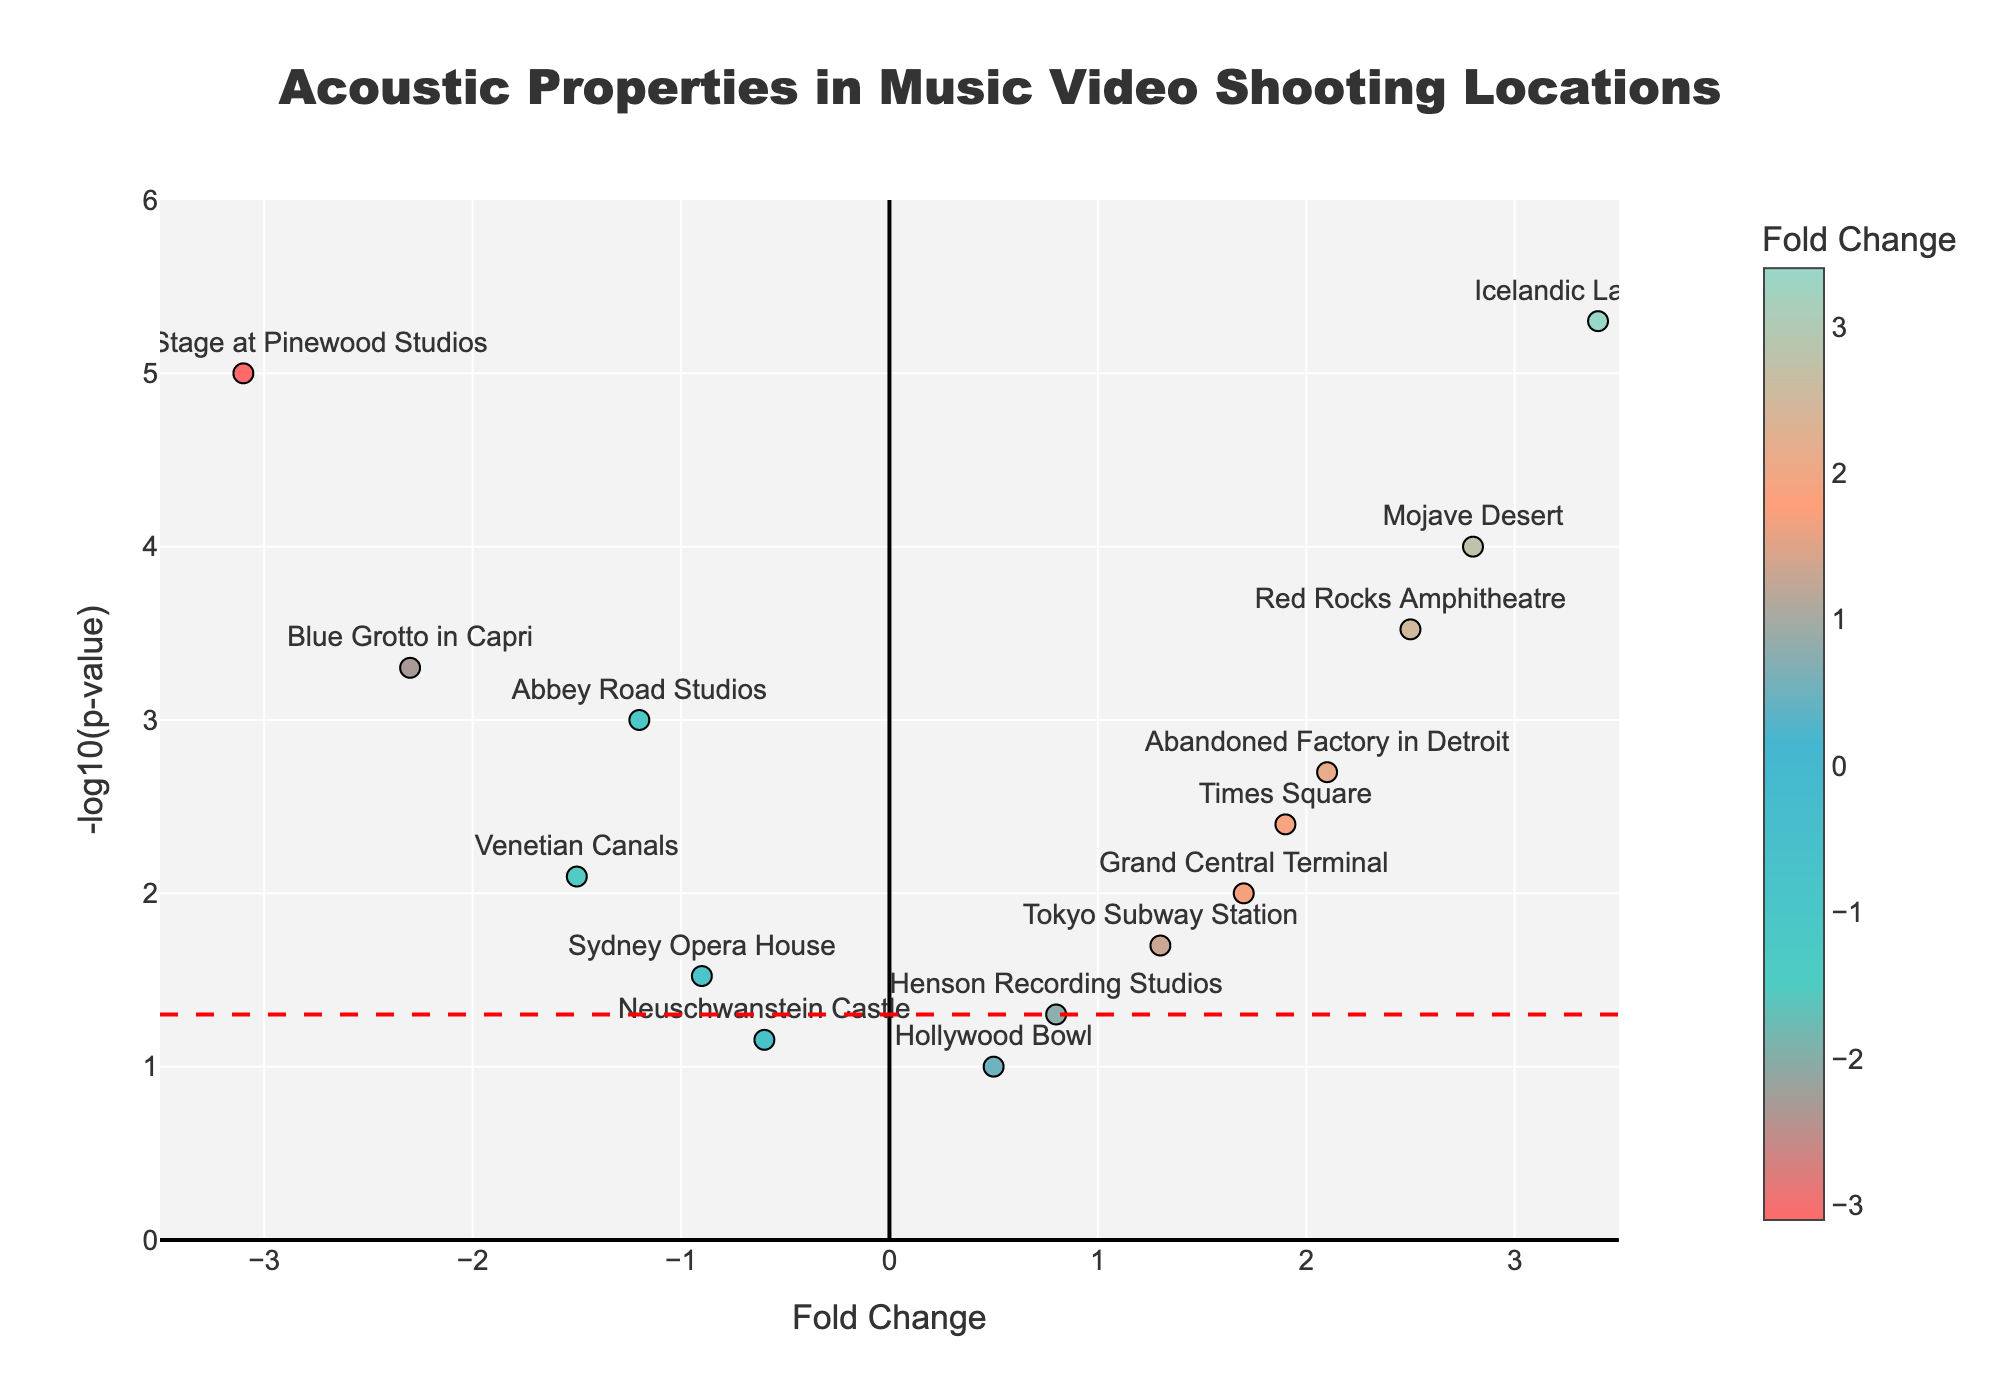What is the title of the figure? The title is often positioned at the top of the plot and provides a summary of what the plot illustrates. In this case, it describes what the analysis is about.
Answer: "Acoustic Properties in Music Video Shooting Locations" What does the figure show on the y-axis? The y-axis typically shows the effect or significance level of data points. In this case, it references the transformed p-value.
Answer: "-log10(p-value)" Which location has the highest fold change? By looking at the x-axis which shows the fold change, we identify the point farthest to the right.
Answer: "Icelandic Lava Field" Which location has the lowest p-value? By examining the y-axis where higher values represent lower p-values, we locate the highest point on the plot.
Answer: "Underwater Stage at Pinewood Studios" How many locations have a fold change greater than 1? Locate and count the number of points that lie to the right of the value 1 on the x-axis.
Answer: 6 Which locations have a fold change less than -1? Count the points to the left of the value -1 on the x-axis to find the relevant locations.
Answer: "Abbey Road Studios," "Venetian Canals," and "Blue Grotto in Capri" What significance level lines are added to the figure? Significance level lines usually indicate common significance thresholds, which are noted as a horizontal red dashed line here.
Answer: -log10(0.05) Which location has a p-value of 0.04? Convert the -log10(p-value) to the original p-value to identify the corresponding point. However, no point on the figure has this exact p-value, indicating none match this criterion.
Answer: None Compare the fold change between "Mojave Desert" and "Red Rocks Amphitheatre". Which one is greater? Identify the two points and compare their x-coordinate values (fold changes).
Answer: "Mojave Desert" What is the fold change and p-value for "Times Square"? Use the provided scatter text annotations or hover text to find the values for "Times Square".
Answer: Fold Change: 1.9, p-value: 0.004 